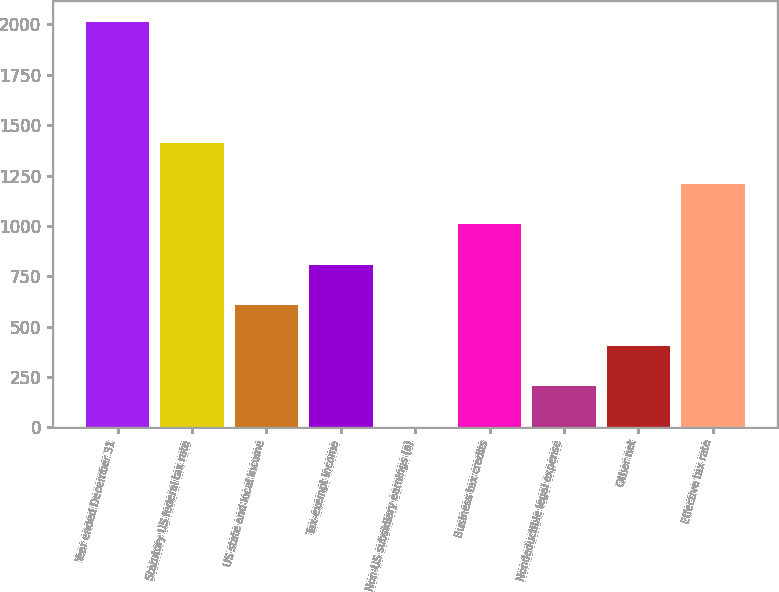Convert chart. <chart><loc_0><loc_0><loc_500><loc_500><bar_chart><fcel>Year ended December 31<fcel>Statutory US federal tax rate<fcel>US state and local income<fcel>Tax-exempt income<fcel>Non-US subsidiary earnings (a)<fcel>Business tax credits<fcel>Nondeductible legal expense<fcel>Other net<fcel>Effective tax rate<nl><fcel>2014<fcel>1410.4<fcel>605.6<fcel>806.8<fcel>2<fcel>1008<fcel>203.2<fcel>404.4<fcel>1209.2<nl></chart> 